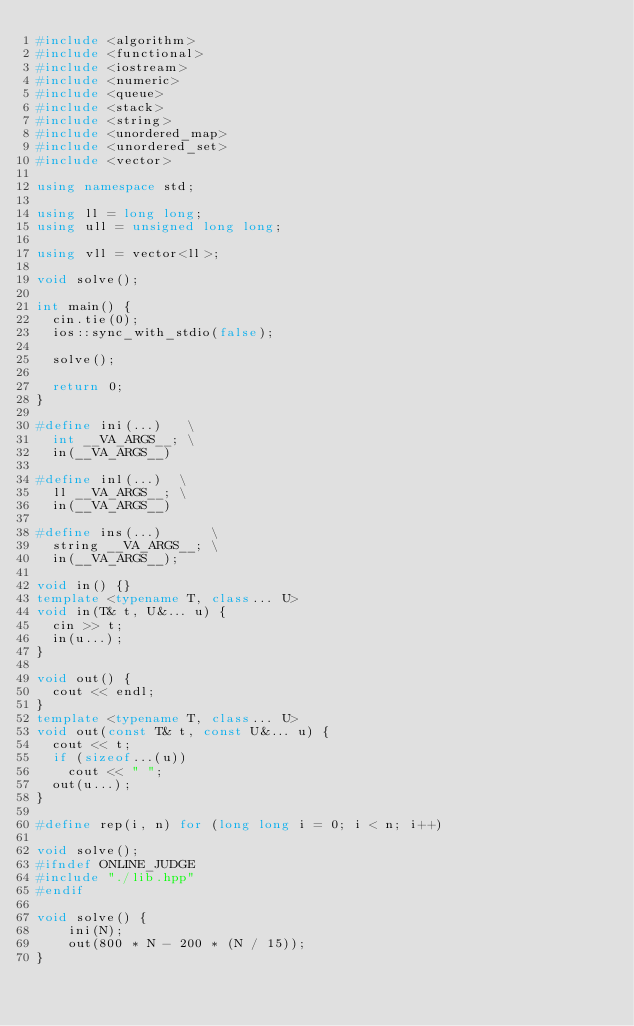Convert code to text. <code><loc_0><loc_0><loc_500><loc_500><_C++_>#include <algorithm>
#include <functional>
#include <iostream>
#include <numeric>
#include <queue>
#include <stack>
#include <string>
#include <unordered_map>
#include <unordered_set>
#include <vector>

using namespace std;

using ll = long long;
using ull = unsigned long long;

using vll = vector<ll>;

void solve();

int main() {
  cin.tie(0);
  ios::sync_with_stdio(false);

  solve();

  return 0;
}

#define ini(...)   \
  int __VA_ARGS__; \
  in(__VA_ARGS__)

#define inl(...)  \
  ll __VA_ARGS__; \
  in(__VA_ARGS__)

#define ins(...)      \
  string __VA_ARGS__; \
  in(__VA_ARGS__);

void in() {}
template <typename T, class... U>
void in(T& t, U&... u) {
  cin >> t;
  in(u...);
}

void out() {
  cout << endl;
}
template <typename T, class... U>
void out(const T& t, const U&... u) {
  cout << t;
  if (sizeof...(u))
    cout << " ";
  out(u...);
}

#define rep(i, n) for (long long i = 0; i < n; i++)

void solve();
#ifndef ONLINE_JUDGE
#include "./lib.hpp"
#endif

void solve() {
    ini(N);
    out(800 * N - 200 * (N / 15));
}
</code> 